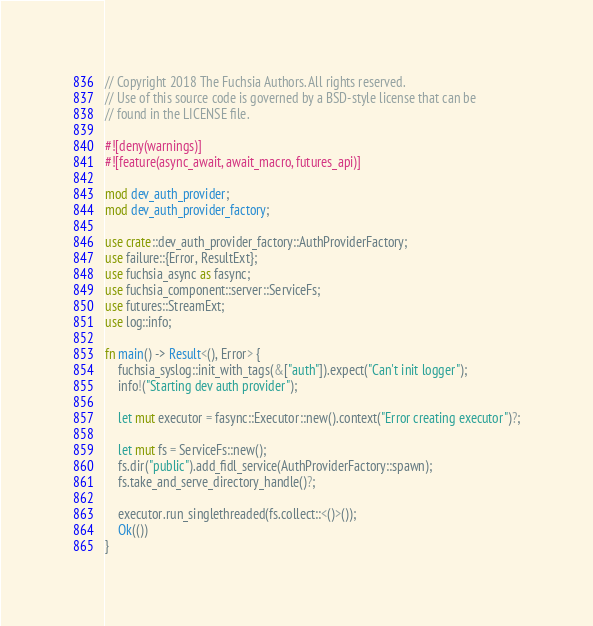Convert code to text. <code><loc_0><loc_0><loc_500><loc_500><_Rust_>// Copyright 2018 The Fuchsia Authors. All rights reserved.
// Use of this source code is governed by a BSD-style license that can be
// found in the LICENSE file.

#![deny(warnings)]
#![feature(async_await, await_macro, futures_api)]

mod dev_auth_provider;
mod dev_auth_provider_factory;

use crate::dev_auth_provider_factory::AuthProviderFactory;
use failure::{Error, ResultExt};
use fuchsia_async as fasync;
use fuchsia_component::server::ServiceFs;
use futures::StreamExt;
use log::info;

fn main() -> Result<(), Error> {
    fuchsia_syslog::init_with_tags(&["auth"]).expect("Can't init logger");
    info!("Starting dev auth provider");

    let mut executor = fasync::Executor::new().context("Error creating executor")?;

    let mut fs = ServiceFs::new();
    fs.dir("public").add_fidl_service(AuthProviderFactory::spawn);
    fs.take_and_serve_directory_handle()?;

    executor.run_singlethreaded(fs.collect::<()>());
    Ok(())
}
</code> 